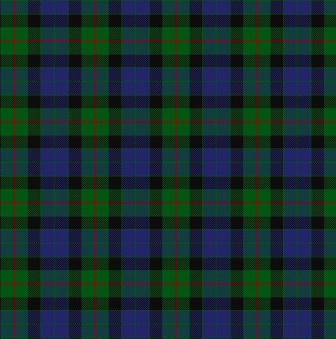What historical significance do tartan designs hold? Tartan designs hold substantial historical significance, particularly in Scottish culture. Historically, tartan patterns were associated with specific Scottish clans and families, functioning as a form of identification in both peacetime and battle. Each clan had unique patterns and colors in their tartans, making it easy to distinguish between different families or regions. These designs were not only used for clothing but also for other textiles, playing an integral role in the cultural heritage and identity of the Scottish people. Over time, tartan has become a symbol of Scotland itself, recognized and worn worldwide. 